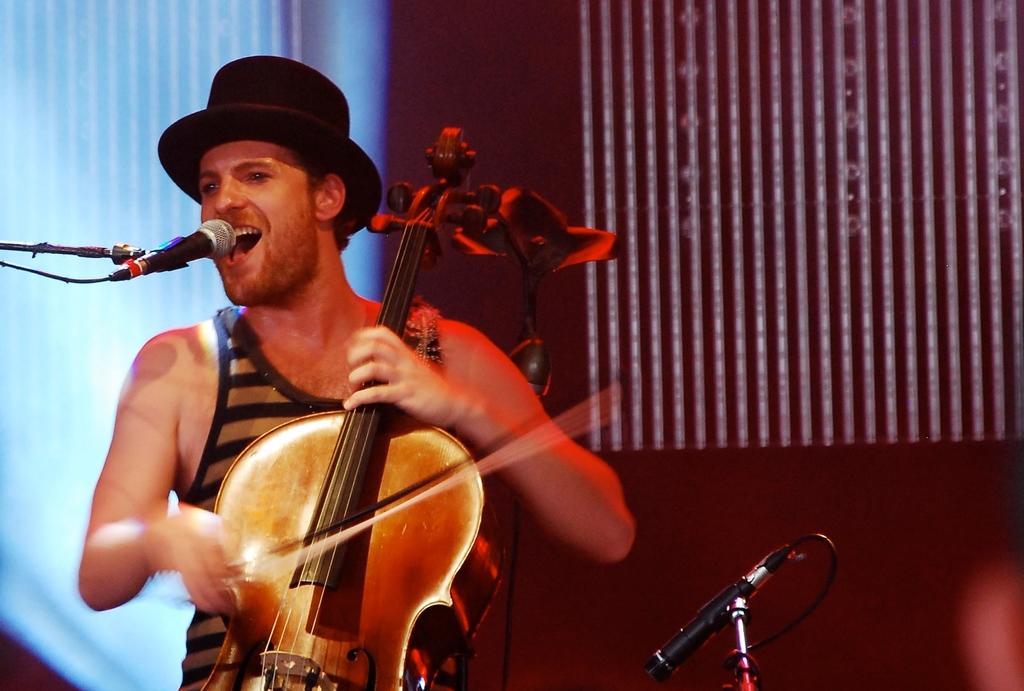How would you summarize this image in a sentence or two? A man is wearing a hat holding a violin and playing. He is singing. In front of him there is a mic and mic stand. In the background there is a wall. There is another mic and mic stand. 